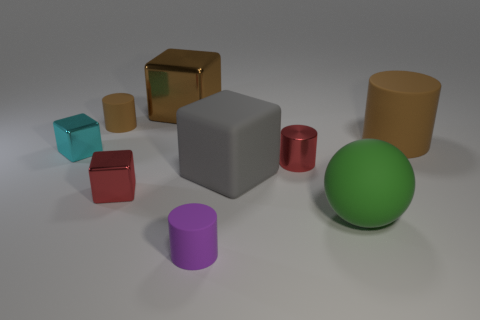Subtract all large cylinders. How many cylinders are left? 3 Subtract all cylinders. How many objects are left? 5 Subtract all brown blocks. How many blocks are left? 3 Subtract 3 cylinders. How many cylinders are left? 1 Subtract all purple spheres. How many brown cylinders are left? 2 Add 5 big rubber balls. How many big rubber balls are left? 6 Add 6 cyan metallic cubes. How many cyan metallic cubes exist? 7 Subtract 2 brown cylinders. How many objects are left? 7 Subtract all cyan balls. Subtract all brown cubes. How many balls are left? 1 Subtract all gray matte blocks. Subtract all green things. How many objects are left? 7 